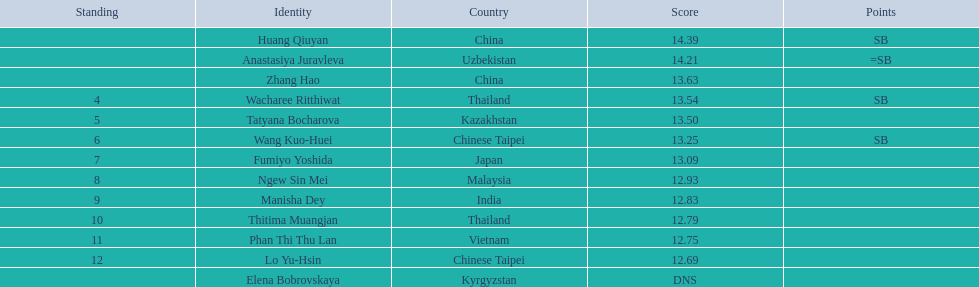What is the difference between huang qiuyan's result and fumiyo yoshida's result? 1.3. 